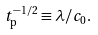<formula> <loc_0><loc_0><loc_500><loc_500>t _ { \text {p} } ^ { - 1 / 2 } \equiv \lambda / c _ { 0 } .</formula> 